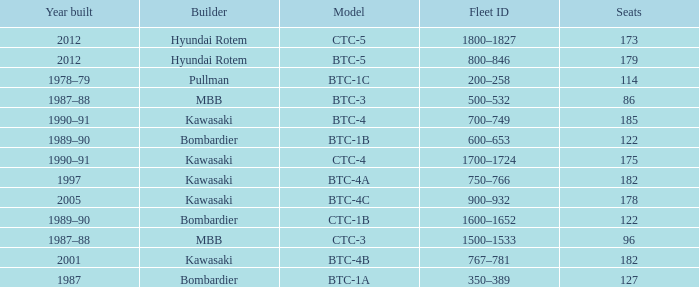Which model has 175 seats? CTC-4. 